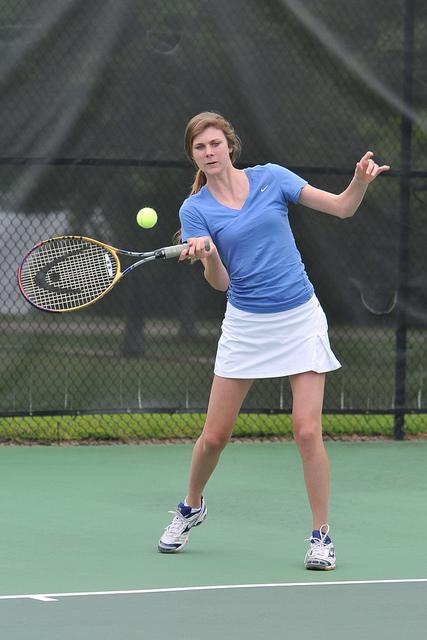What color is the girl's shirt?
Give a very brief answer. Blue. Is she a beginner?
Give a very brief answer. Yes. What color is her shirt?
Concise answer only. Blue. What is she holding in her right hand?
Keep it brief. Tennis racket. 